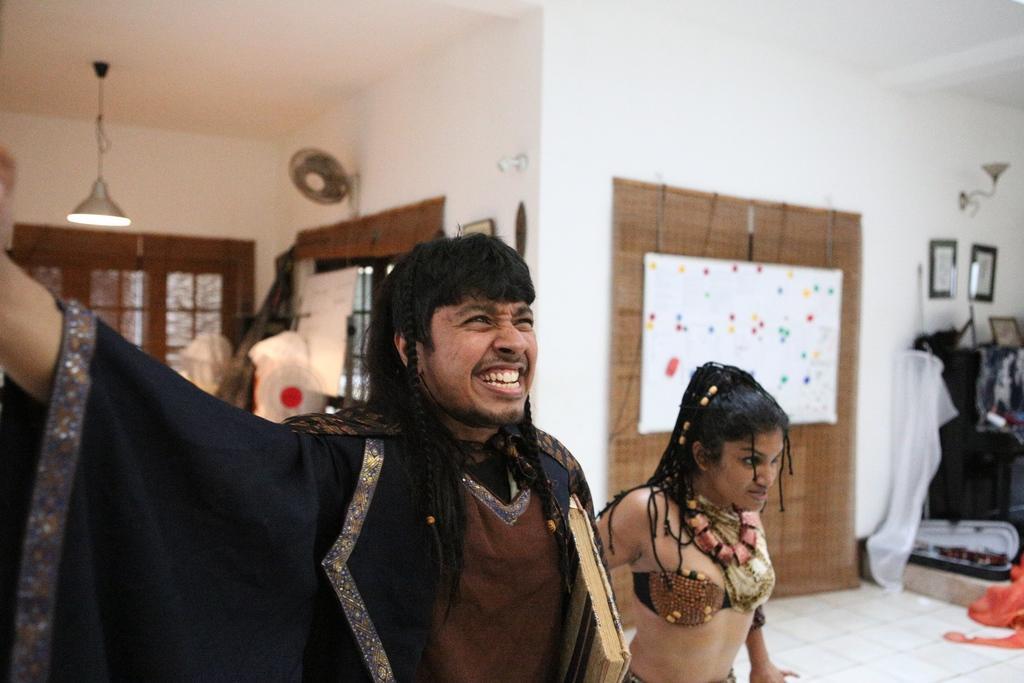How would you summarize this image in a sentence or two? In this image we can see a man and woman. In the background we can see windows, objects, light hanging to the ceiling, boards, frames on the wall, clothes, light on the wall, other objects and we can see the floor. 